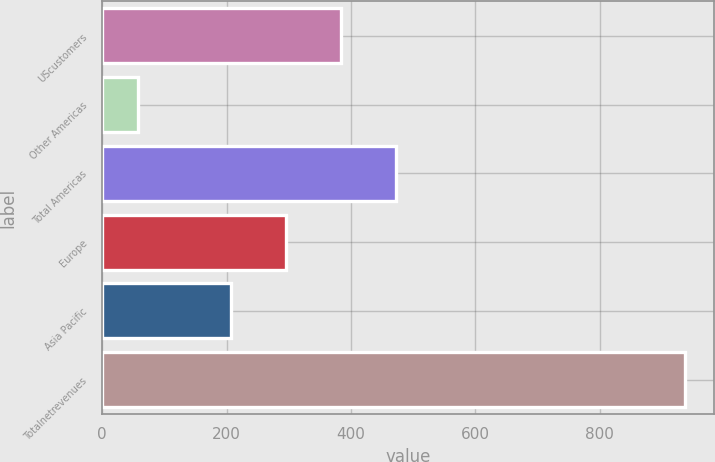Convert chart to OTSL. <chart><loc_0><loc_0><loc_500><loc_500><bar_chart><fcel>UScustomers<fcel>Other Americas<fcel>Total Americas<fcel>Europe<fcel>Asia Pacific<fcel>Totalnetrevenues<nl><fcel>383.85<fcel>57.8<fcel>471.7<fcel>296<fcel>207.6<fcel>936.3<nl></chart> 